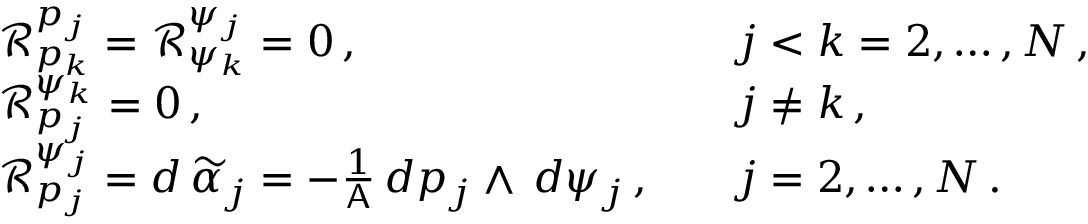Convert formula to latex. <formula><loc_0><loc_0><loc_500><loc_500>\begin{array} { r l r l } & { \mathcal { R } ^ { p _ { j } } _ { p _ { k } } = \mathcal { R } ^ { \psi _ { j } } _ { \psi _ { k } } = 0 \, , } & & { j < k = 2 , \hdots , N \, , } \\ & { \mathcal { R } ^ { \psi _ { k } } _ { p _ { j } } = 0 \, , } & & { j \neq k \, , } \\ & { \mathcal { R } ^ { \psi _ { j } } _ { p _ { j } } = d \, \widetilde { \alpha } _ { j } = - \frac { 1 } { A } \, d p _ { j } \wedge \, d \psi _ { j } \, , } & & { j = 2 , \hdots , N \, . } \end{array}</formula> 